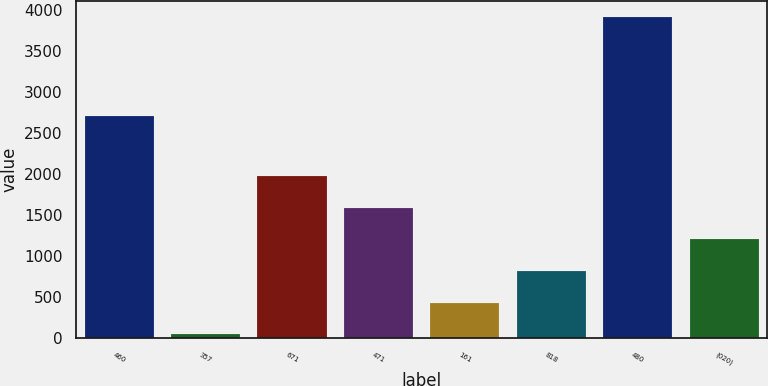Convert chart to OTSL. <chart><loc_0><loc_0><loc_500><loc_500><bar_chart><fcel>460<fcel>357<fcel>671<fcel>471<fcel>161<fcel>818<fcel>480<fcel>(020)<nl><fcel>2709<fcel>48<fcel>1982.5<fcel>1595.6<fcel>434.9<fcel>821.8<fcel>3917<fcel>1208.7<nl></chart> 